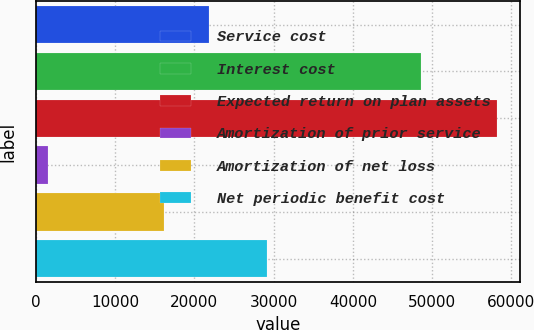Convert chart. <chart><loc_0><loc_0><loc_500><loc_500><bar_chart><fcel>Service cost<fcel>Interest cost<fcel>Expected return on plan assets<fcel>Amortization of prior service<fcel>Amortization of net loss<fcel>Net periodic benefit cost<nl><fcel>21805.8<fcel>48608<fcel>58154<fcel>1486<fcel>16139<fcel>29129<nl></chart> 